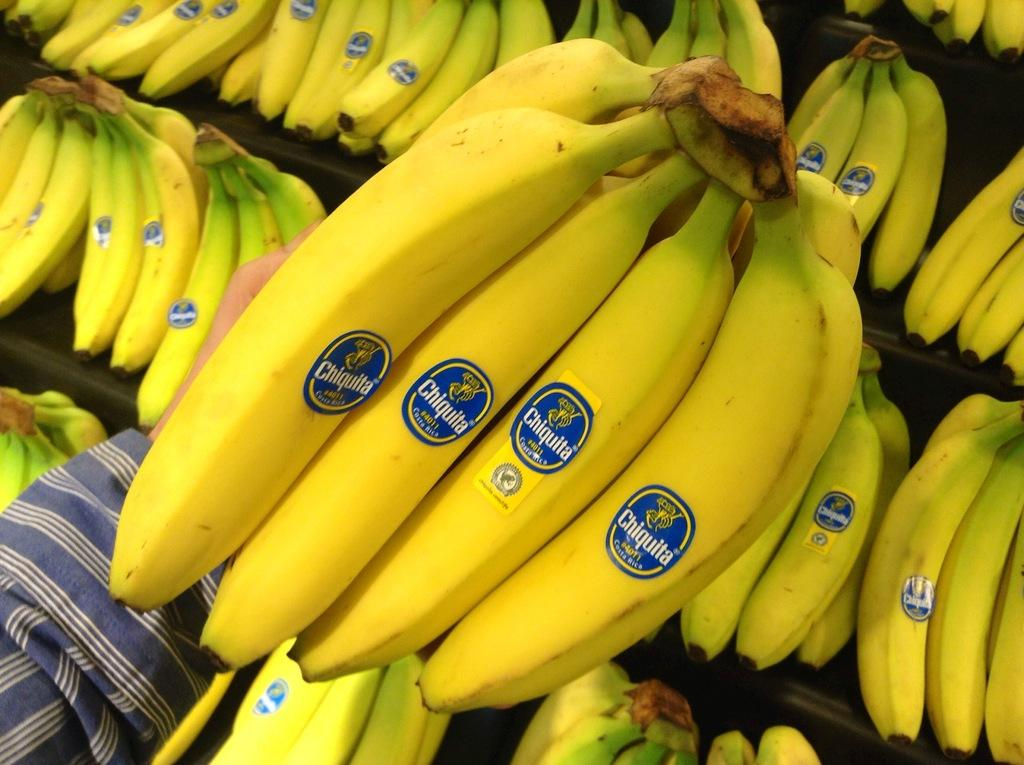What type of fruit is visible in the image? There are bananas in the image. What color are the bananas? The bananas are yellow. Whose hand is holding the bananas in the image? There is a person's hand holding the bananas in the image. What time of day is it in the image? The time of day cannot be determined from the image, as there are no clues or context provided. 